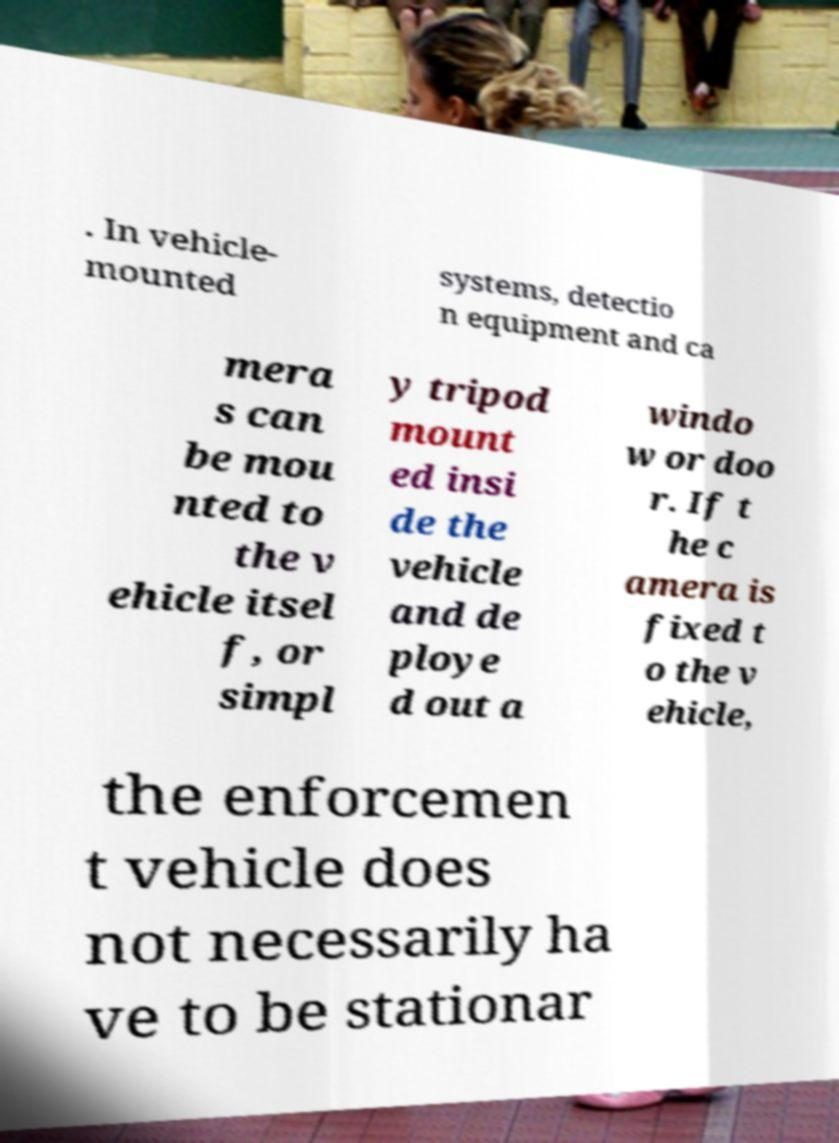Please identify and transcribe the text found in this image. . In vehicle- mounted systems, detectio n equipment and ca mera s can be mou nted to the v ehicle itsel f, or simpl y tripod mount ed insi de the vehicle and de ploye d out a windo w or doo r. If t he c amera is fixed t o the v ehicle, the enforcemen t vehicle does not necessarily ha ve to be stationar 